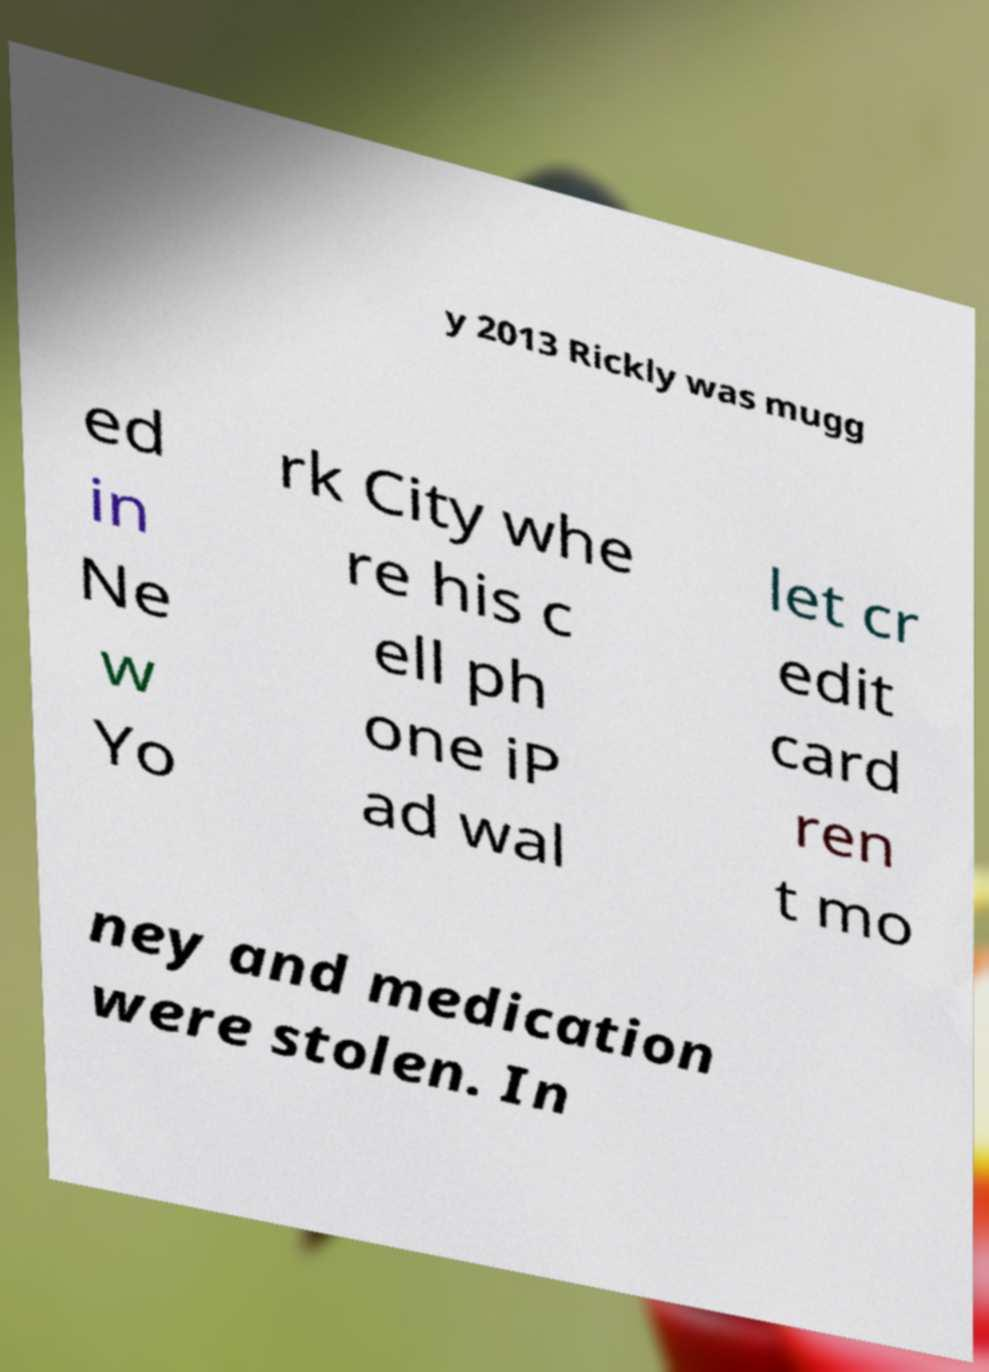There's text embedded in this image that I need extracted. Can you transcribe it verbatim? y 2013 Rickly was mugg ed in Ne w Yo rk City whe re his c ell ph one iP ad wal let cr edit card ren t mo ney and medication were stolen. In 